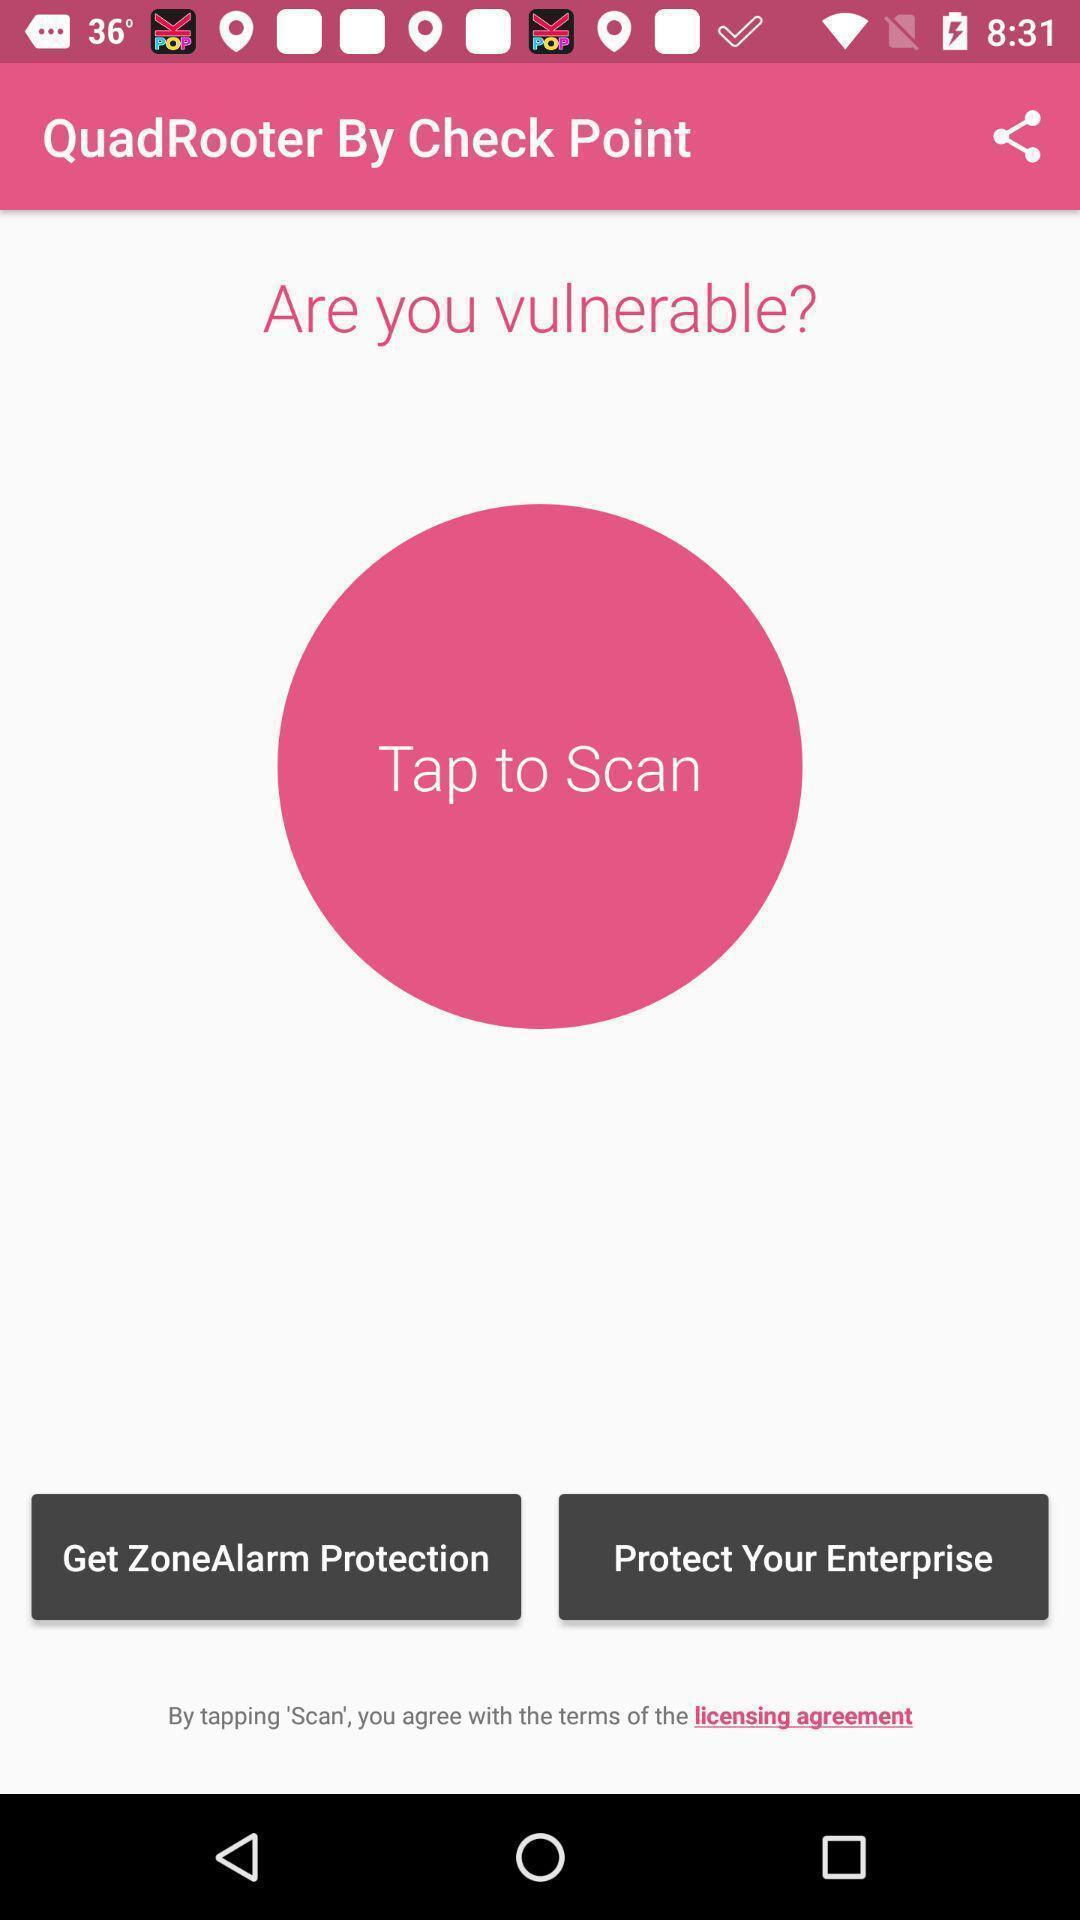Provide a description of this screenshot. Screen displaying an app asking to tap to scan. 